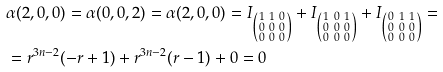<formula> <loc_0><loc_0><loc_500><loc_500>& \alpha ( 2 , 0 , 0 ) = \alpha ( 0 , 0 , 2 ) = \alpha ( 2 , 0 , 0 ) = I _ { \left ( \begin{smallmatrix} 1 & 1 & 0 \\ 0 & 0 & 0 \\ 0 & 0 & 0 \end{smallmatrix} \right ) } + I _ { \left ( \begin{smallmatrix} 1 & 0 & 1 \\ 0 & 0 & 0 \\ 0 & 0 & 0 \end{smallmatrix} \right ) } + I _ { \left ( \begin{smallmatrix} 0 & 1 & 1 \\ 0 & 0 & 0 \\ 0 & 0 & 0 \end{smallmatrix} \right ) } = \\ & = r ^ { 3 n - 2 } ( - r + 1 ) + r ^ { 3 n - 2 } ( r - 1 ) + 0 = 0</formula> 